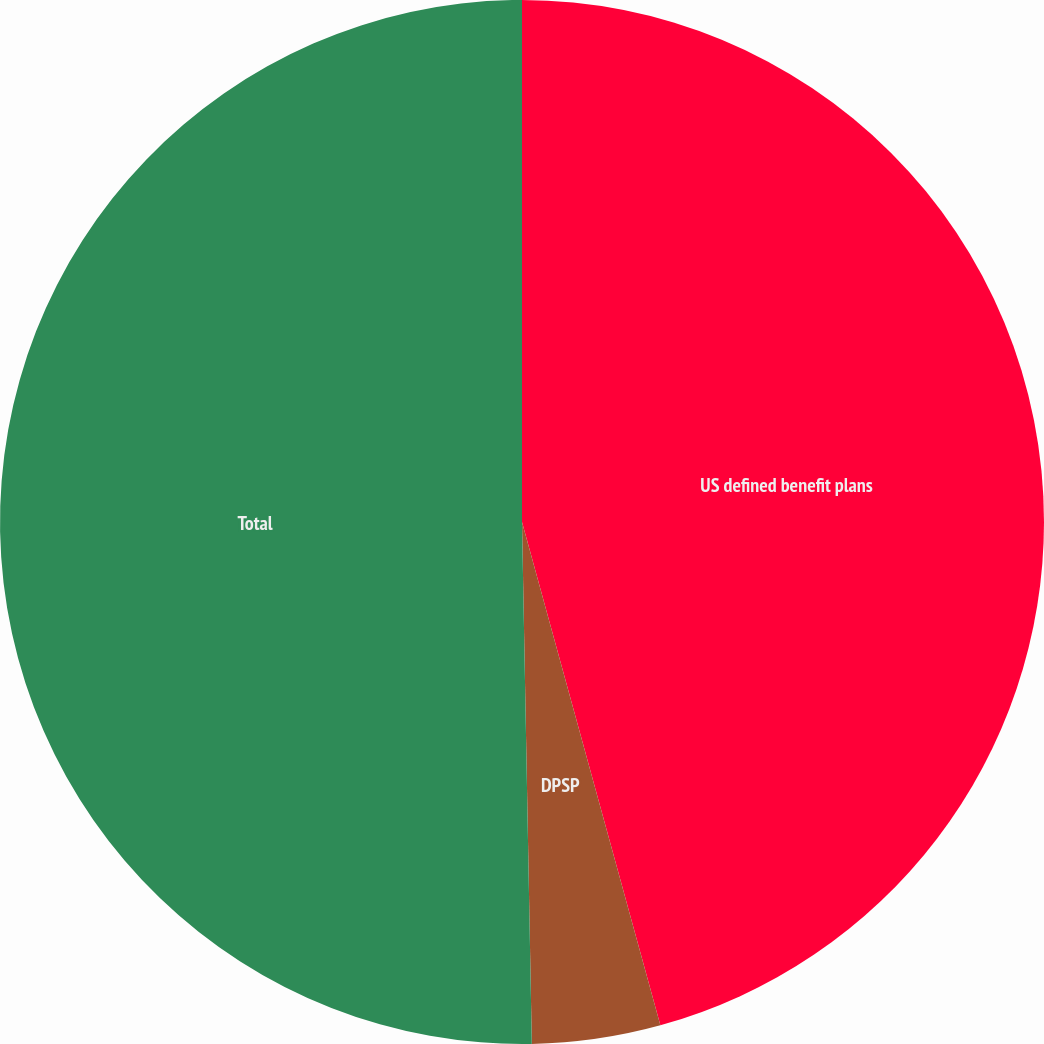<chart> <loc_0><loc_0><loc_500><loc_500><pie_chart><fcel>US defined benefit plans<fcel>DPSP<fcel>Total<nl><fcel>45.73%<fcel>3.97%<fcel>50.3%<nl></chart> 